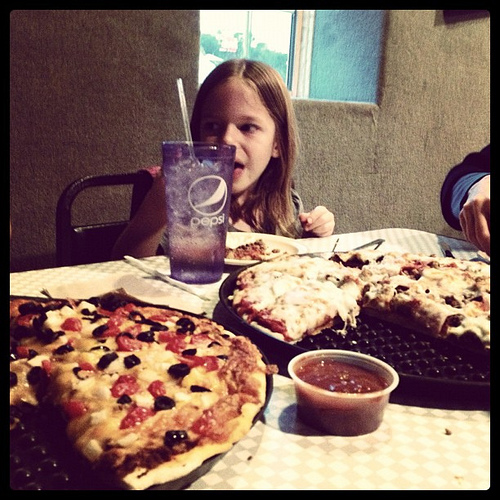Is there anything that indicates how many people are eating? The image shows a meal set up for at least two people, as evidenced by a pair of pizzas and two visible plates. However, the exact number of diners cannot be confirmed just from this view. 